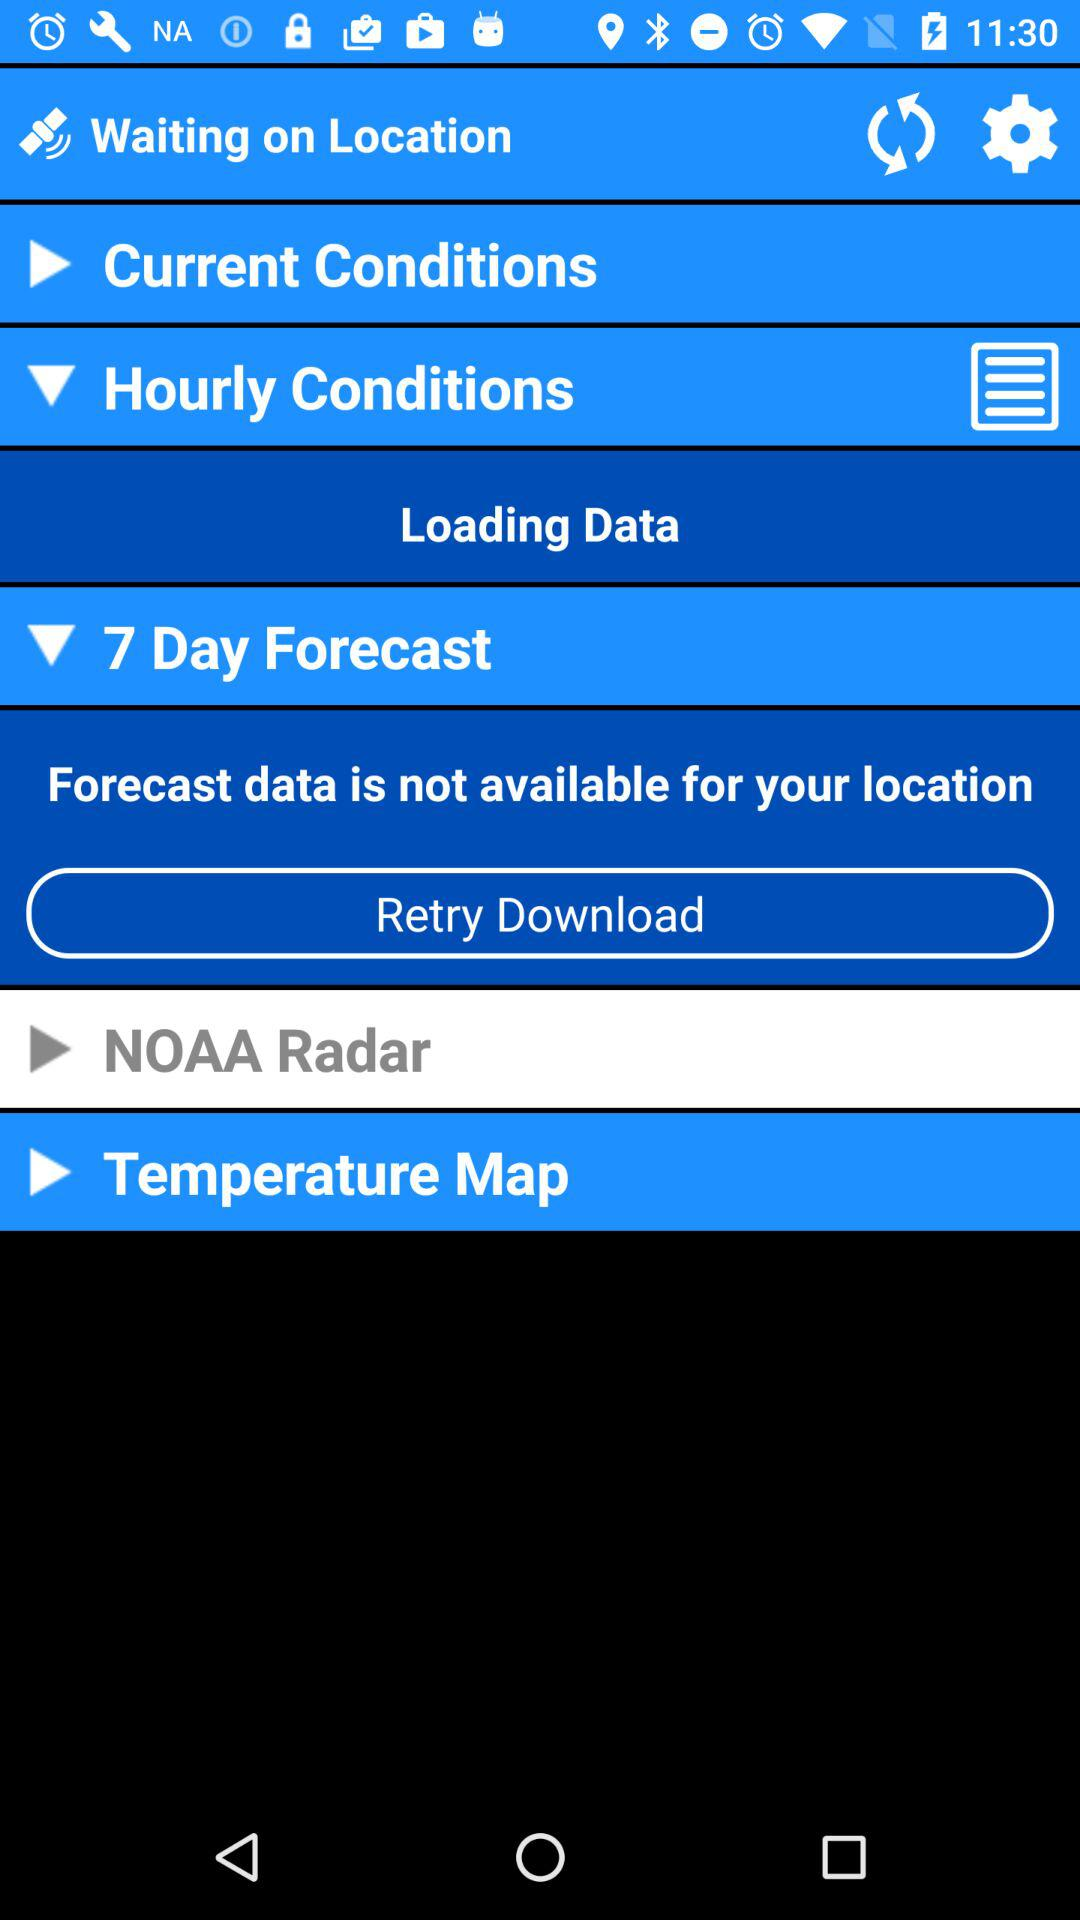How many items are disabled?
Answer the question using a single word or phrase. 2 